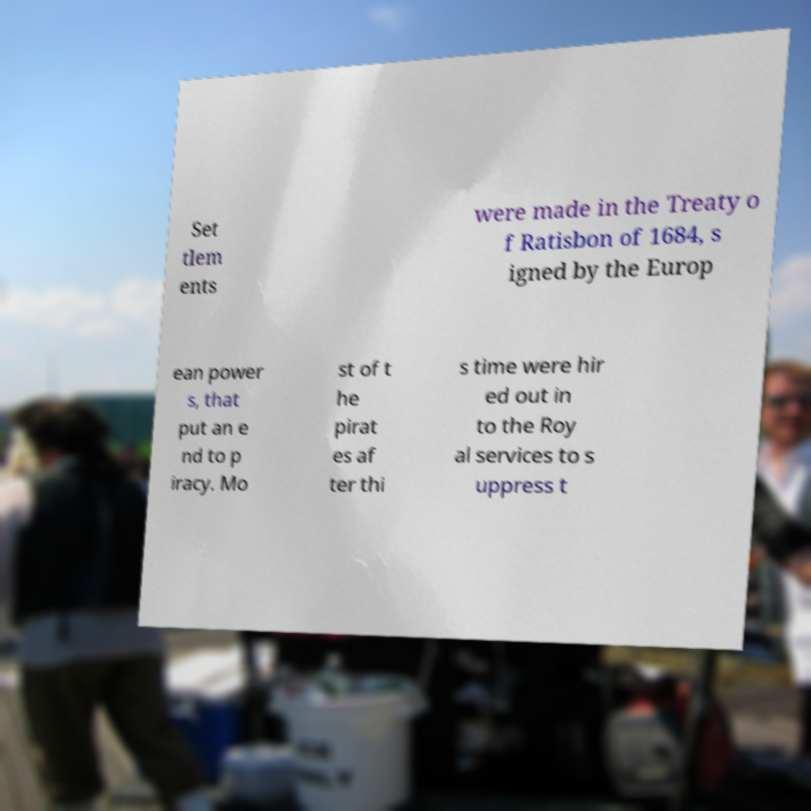Can you read and provide the text displayed in the image?This photo seems to have some interesting text. Can you extract and type it out for me? Set tlem ents were made in the Treaty o f Ratisbon of 1684, s igned by the Europ ean power s, that put an e nd to p iracy. Mo st of t he pirat es af ter thi s time were hir ed out in to the Roy al services to s uppress t 